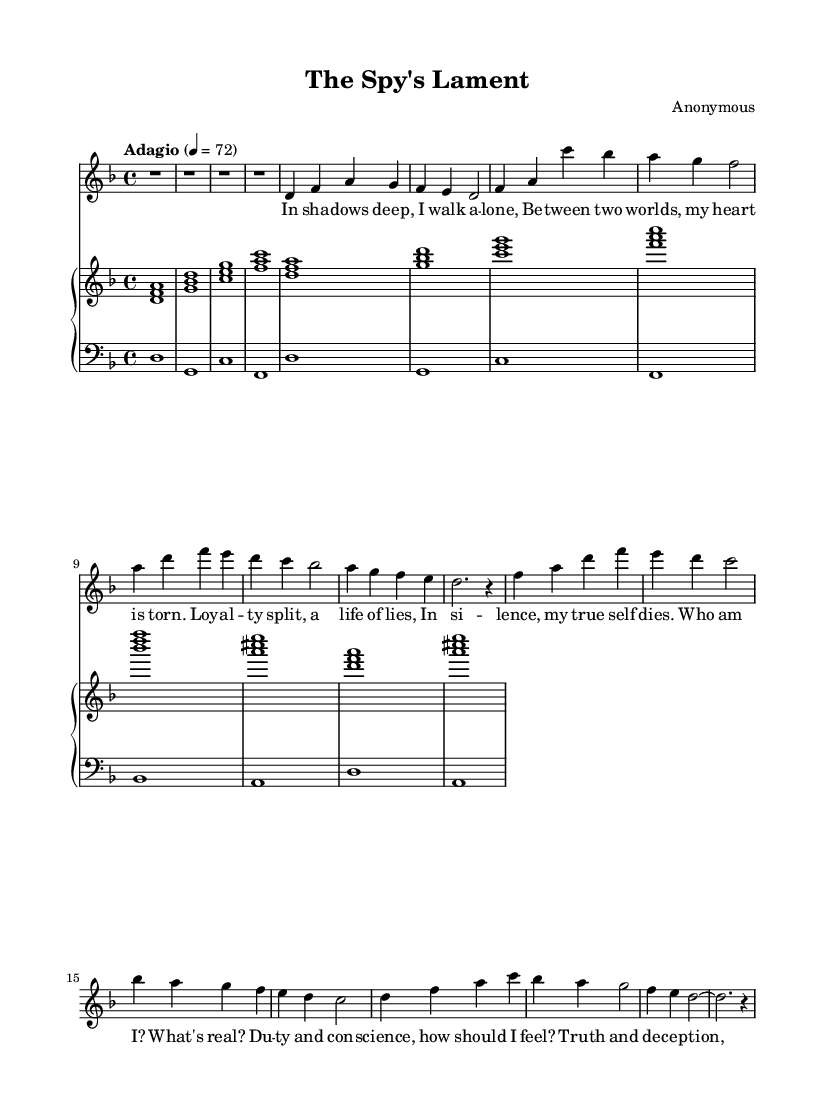What is the key signature of this music? The key signature is indicated by the presence of one flat on the staff, which corresponds to the key of D minor.
Answer: D minor What is the time signature of this piece? The time signature is shown at the beginning of the music and is written as a fraction, indicating 4 beats per measure.
Answer: 4/4 What is the tempo marking for this composition? The tempo marking, written above the staff, specifies the speed at which the music should be played; in this case, it indicates an adagio tempo.
Answer: Adagio How many measures are in the verse section? By counting the distinct groupings of notes and rests in the verse section, we find there are a total of 8 measures.
Answer: 8 What emotions are conveyed in the lyrics of the aria? The lyrics depict feelings of isolation, inner conflict, and questioning one's identity, corresponding to themes of double agents and deception.
Answer: Isolation What type of musical structure is used in this piece (e.g., verse-chorus)? The structure of the piece consists of a verse followed by a chorus, a common format in operatic arias.
Answer: Verse-Chorus How is the piano accompaniment characterized in this piece? The piano accompaniment uses chords played in a steady rhythm, supporting the vocal melody while also enhancing the emotional depth of the aria.
Answer: Chordal 